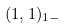Convert formula to latex. <formula><loc_0><loc_0><loc_500><loc_500>( 1 , 1 ) _ { 1 - }</formula> 